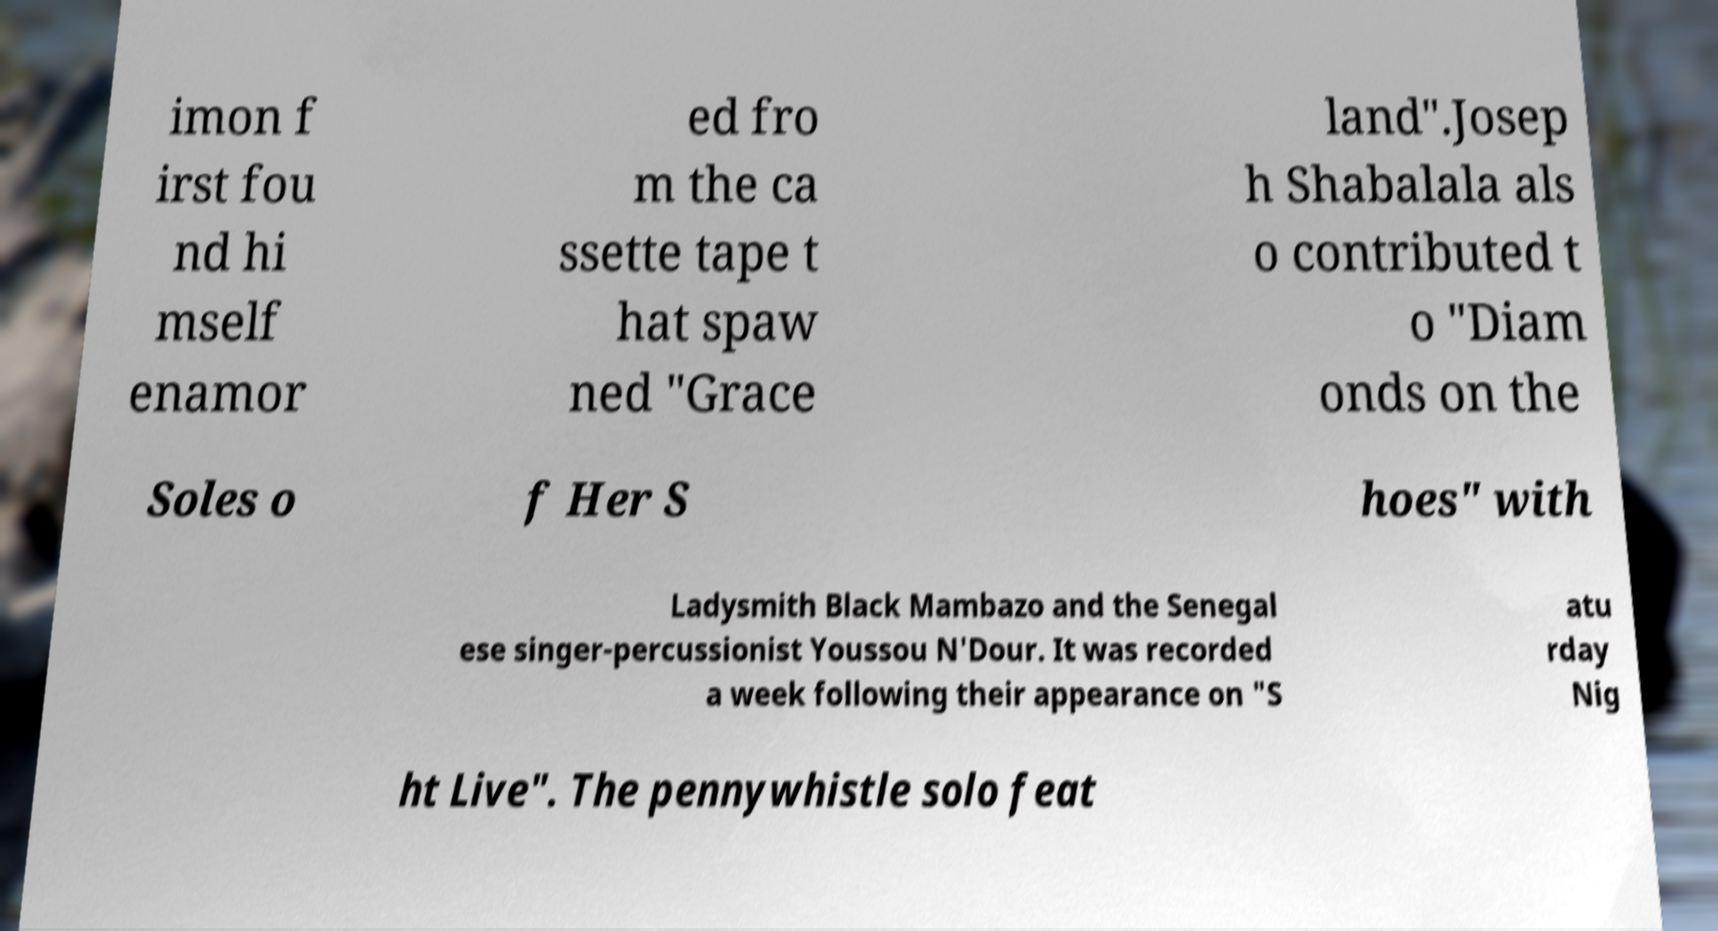There's text embedded in this image that I need extracted. Can you transcribe it verbatim? imon f irst fou nd hi mself enamor ed fro m the ca ssette tape t hat spaw ned "Grace land".Josep h Shabalala als o contributed t o "Diam onds on the Soles o f Her S hoes" with Ladysmith Black Mambazo and the Senegal ese singer-percussionist Youssou N'Dour. It was recorded a week following their appearance on "S atu rday Nig ht Live". The pennywhistle solo feat 